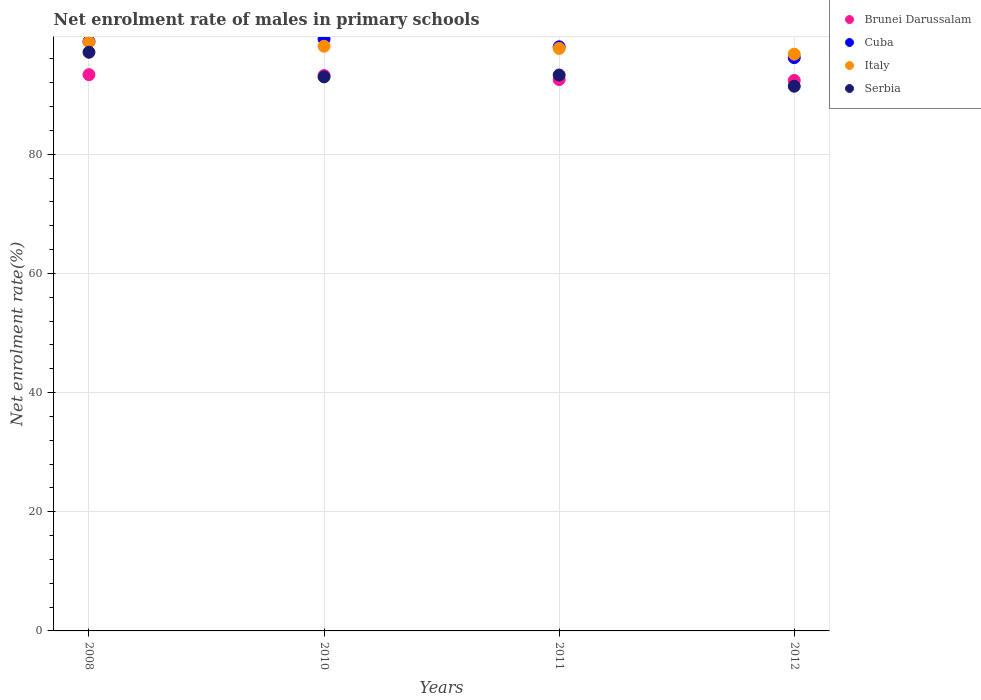How many different coloured dotlines are there?
Offer a terse response. 4. Is the number of dotlines equal to the number of legend labels?
Ensure brevity in your answer.  Yes. What is the net enrolment rate of males in primary schools in Serbia in 2012?
Your answer should be compact. 91.43. Across all years, what is the maximum net enrolment rate of males in primary schools in Cuba?
Offer a terse response. 99.36. Across all years, what is the minimum net enrolment rate of males in primary schools in Cuba?
Offer a very short reply. 96.22. What is the total net enrolment rate of males in primary schools in Serbia in the graph?
Ensure brevity in your answer.  374.85. What is the difference between the net enrolment rate of males in primary schools in Cuba in 2008 and that in 2010?
Keep it short and to the point. -0.42. What is the difference between the net enrolment rate of males in primary schools in Serbia in 2011 and the net enrolment rate of males in primary schools in Italy in 2008?
Provide a short and direct response. -5.55. What is the average net enrolment rate of males in primary schools in Italy per year?
Give a very brief answer. 97.89. In the year 2011, what is the difference between the net enrolment rate of males in primary schools in Serbia and net enrolment rate of males in primary schools in Brunei Darussalam?
Your answer should be very brief. 0.76. In how many years, is the net enrolment rate of males in primary schools in Italy greater than 76 %?
Provide a short and direct response. 4. What is the ratio of the net enrolment rate of males in primary schools in Brunei Darussalam in 2008 to that in 2010?
Your answer should be very brief. 1. What is the difference between the highest and the second highest net enrolment rate of males in primary schools in Brunei Darussalam?
Make the answer very short. 0.15. What is the difference between the highest and the lowest net enrolment rate of males in primary schools in Italy?
Provide a short and direct response. 2.05. Is the sum of the net enrolment rate of males in primary schools in Cuba in 2008 and 2010 greater than the maximum net enrolment rate of males in primary schools in Brunei Darussalam across all years?
Offer a terse response. Yes. Is it the case that in every year, the sum of the net enrolment rate of males in primary schools in Cuba and net enrolment rate of males in primary schools in Serbia  is greater than the sum of net enrolment rate of males in primary schools in Italy and net enrolment rate of males in primary schools in Brunei Darussalam?
Provide a succinct answer. Yes. Is it the case that in every year, the sum of the net enrolment rate of males in primary schools in Brunei Darussalam and net enrolment rate of males in primary schools in Italy  is greater than the net enrolment rate of males in primary schools in Serbia?
Keep it short and to the point. Yes. How many dotlines are there?
Make the answer very short. 4. How many years are there in the graph?
Keep it short and to the point. 4. What is the difference between two consecutive major ticks on the Y-axis?
Provide a succinct answer. 20. Are the values on the major ticks of Y-axis written in scientific E-notation?
Your answer should be compact. No. Does the graph contain any zero values?
Your answer should be compact. No. Does the graph contain grids?
Give a very brief answer. Yes. How many legend labels are there?
Provide a short and direct response. 4. What is the title of the graph?
Provide a succinct answer. Net enrolment rate of males in primary schools. What is the label or title of the Y-axis?
Your answer should be compact. Net enrolment rate(%). What is the Net enrolment rate(%) in Brunei Darussalam in 2008?
Provide a short and direct response. 93.37. What is the Net enrolment rate(%) of Cuba in 2008?
Your answer should be compact. 98.94. What is the Net enrolment rate(%) of Italy in 2008?
Provide a succinct answer. 98.85. What is the Net enrolment rate(%) of Serbia in 2008?
Your response must be concise. 97.13. What is the Net enrolment rate(%) of Brunei Darussalam in 2010?
Your response must be concise. 93.22. What is the Net enrolment rate(%) in Cuba in 2010?
Your answer should be compact. 99.36. What is the Net enrolment rate(%) of Italy in 2010?
Provide a succinct answer. 98.13. What is the Net enrolment rate(%) in Serbia in 2010?
Offer a very short reply. 92.99. What is the Net enrolment rate(%) of Brunei Darussalam in 2011?
Give a very brief answer. 92.54. What is the Net enrolment rate(%) in Cuba in 2011?
Your answer should be compact. 98.04. What is the Net enrolment rate(%) in Italy in 2011?
Provide a short and direct response. 97.76. What is the Net enrolment rate(%) of Serbia in 2011?
Offer a terse response. 93.3. What is the Net enrolment rate(%) of Brunei Darussalam in 2012?
Your answer should be compact. 92.39. What is the Net enrolment rate(%) in Cuba in 2012?
Give a very brief answer. 96.22. What is the Net enrolment rate(%) in Italy in 2012?
Offer a terse response. 96.8. What is the Net enrolment rate(%) of Serbia in 2012?
Your answer should be very brief. 91.43. Across all years, what is the maximum Net enrolment rate(%) of Brunei Darussalam?
Provide a succinct answer. 93.37. Across all years, what is the maximum Net enrolment rate(%) in Cuba?
Your answer should be very brief. 99.36. Across all years, what is the maximum Net enrolment rate(%) in Italy?
Ensure brevity in your answer.  98.85. Across all years, what is the maximum Net enrolment rate(%) in Serbia?
Provide a succinct answer. 97.13. Across all years, what is the minimum Net enrolment rate(%) in Brunei Darussalam?
Offer a very short reply. 92.39. Across all years, what is the minimum Net enrolment rate(%) of Cuba?
Provide a succinct answer. 96.22. Across all years, what is the minimum Net enrolment rate(%) of Italy?
Give a very brief answer. 96.8. Across all years, what is the minimum Net enrolment rate(%) in Serbia?
Give a very brief answer. 91.43. What is the total Net enrolment rate(%) in Brunei Darussalam in the graph?
Offer a terse response. 371.52. What is the total Net enrolment rate(%) in Cuba in the graph?
Your answer should be compact. 392.57. What is the total Net enrolment rate(%) of Italy in the graph?
Your answer should be very brief. 391.55. What is the total Net enrolment rate(%) of Serbia in the graph?
Give a very brief answer. 374.85. What is the difference between the Net enrolment rate(%) in Brunei Darussalam in 2008 and that in 2010?
Your response must be concise. 0.15. What is the difference between the Net enrolment rate(%) in Cuba in 2008 and that in 2010?
Provide a succinct answer. -0.42. What is the difference between the Net enrolment rate(%) of Italy in 2008 and that in 2010?
Your answer should be very brief. 0.72. What is the difference between the Net enrolment rate(%) in Serbia in 2008 and that in 2010?
Provide a short and direct response. 4.13. What is the difference between the Net enrolment rate(%) in Brunei Darussalam in 2008 and that in 2011?
Your response must be concise. 0.82. What is the difference between the Net enrolment rate(%) of Cuba in 2008 and that in 2011?
Your answer should be very brief. 0.9. What is the difference between the Net enrolment rate(%) of Italy in 2008 and that in 2011?
Your answer should be very brief. 1.09. What is the difference between the Net enrolment rate(%) of Serbia in 2008 and that in 2011?
Provide a succinct answer. 3.82. What is the difference between the Net enrolment rate(%) of Brunei Darussalam in 2008 and that in 2012?
Your answer should be very brief. 0.98. What is the difference between the Net enrolment rate(%) in Cuba in 2008 and that in 2012?
Offer a very short reply. 2.73. What is the difference between the Net enrolment rate(%) in Italy in 2008 and that in 2012?
Offer a very short reply. 2.05. What is the difference between the Net enrolment rate(%) in Serbia in 2008 and that in 2012?
Ensure brevity in your answer.  5.7. What is the difference between the Net enrolment rate(%) in Brunei Darussalam in 2010 and that in 2011?
Your response must be concise. 0.67. What is the difference between the Net enrolment rate(%) in Cuba in 2010 and that in 2011?
Ensure brevity in your answer.  1.32. What is the difference between the Net enrolment rate(%) in Italy in 2010 and that in 2011?
Your answer should be very brief. 0.37. What is the difference between the Net enrolment rate(%) in Serbia in 2010 and that in 2011?
Your response must be concise. -0.31. What is the difference between the Net enrolment rate(%) of Brunei Darussalam in 2010 and that in 2012?
Provide a short and direct response. 0.83. What is the difference between the Net enrolment rate(%) of Cuba in 2010 and that in 2012?
Your response must be concise. 3.14. What is the difference between the Net enrolment rate(%) of Italy in 2010 and that in 2012?
Provide a succinct answer. 1.33. What is the difference between the Net enrolment rate(%) of Serbia in 2010 and that in 2012?
Provide a short and direct response. 1.57. What is the difference between the Net enrolment rate(%) in Brunei Darussalam in 2011 and that in 2012?
Offer a terse response. 0.15. What is the difference between the Net enrolment rate(%) of Cuba in 2011 and that in 2012?
Provide a succinct answer. 1.82. What is the difference between the Net enrolment rate(%) in Italy in 2011 and that in 2012?
Offer a terse response. 0.96. What is the difference between the Net enrolment rate(%) of Serbia in 2011 and that in 2012?
Offer a terse response. 1.88. What is the difference between the Net enrolment rate(%) in Brunei Darussalam in 2008 and the Net enrolment rate(%) in Cuba in 2010?
Offer a terse response. -5.99. What is the difference between the Net enrolment rate(%) of Brunei Darussalam in 2008 and the Net enrolment rate(%) of Italy in 2010?
Your answer should be very brief. -4.77. What is the difference between the Net enrolment rate(%) in Brunei Darussalam in 2008 and the Net enrolment rate(%) in Serbia in 2010?
Give a very brief answer. 0.37. What is the difference between the Net enrolment rate(%) in Cuba in 2008 and the Net enrolment rate(%) in Italy in 2010?
Provide a succinct answer. 0.81. What is the difference between the Net enrolment rate(%) of Cuba in 2008 and the Net enrolment rate(%) of Serbia in 2010?
Keep it short and to the point. 5.95. What is the difference between the Net enrolment rate(%) in Italy in 2008 and the Net enrolment rate(%) in Serbia in 2010?
Provide a succinct answer. 5.86. What is the difference between the Net enrolment rate(%) in Brunei Darussalam in 2008 and the Net enrolment rate(%) in Cuba in 2011?
Make the answer very short. -4.68. What is the difference between the Net enrolment rate(%) of Brunei Darussalam in 2008 and the Net enrolment rate(%) of Italy in 2011?
Make the answer very short. -4.39. What is the difference between the Net enrolment rate(%) in Brunei Darussalam in 2008 and the Net enrolment rate(%) in Serbia in 2011?
Your answer should be compact. 0.06. What is the difference between the Net enrolment rate(%) of Cuba in 2008 and the Net enrolment rate(%) of Italy in 2011?
Your answer should be compact. 1.18. What is the difference between the Net enrolment rate(%) in Cuba in 2008 and the Net enrolment rate(%) in Serbia in 2011?
Offer a terse response. 5.64. What is the difference between the Net enrolment rate(%) of Italy in 2008 and the Net enrolment rate(%) of Serbia in 2011?
Your answer should be very brief. 5.55. What is the difference between the Net enrolment rate(%) of Brunei Darussalam in 2008 and the Net enrolment rate(%) of Cuba in 2012?
Ensure brevity in your answer.  -2.85. What is the difference between the Net enrolment rate(%) of Brunei Darussalam in 2008 and the Net enrolment rate(%) of Italy in 2012?
Keep it short and to the point. -3.43. What is the difference between the Net enrolment rate(%) in Brunei Darussalam in 2008 and the Net enrolment rate(%) in Serbia in 2012?
Your response must be concise. 1.94. What is the difference between the Net enrolment rate(%) in Cuba in 2008 and the Net enrolment rate(%) in Italy in 2012?
Offer a very short reply. 2.14. What is the difference between the Net enrolment rate(%) of Cuba in 2008 and the Net enrolment rate(%) of Serbia in 2012?
Provide a short and direct response. 7.52. What is the difference between the Net enrolment rate(%) in Italy in 2008 and the Net enrolment rate(%) in Serbia in 2012?
Offer a terse response. 7.43. What is the difference between the Net enrolment rate(%) of Brunei Darussalam in 2010 and the Net enrolment rate(%) of Cuba in 2011?
Offer a very short reply. -4.83. What is the difference between the Net enrolment rate(%) in Brunei Darussalam in 2010 and the Net enrolment rate(%) in Italy in 2011?
Provide a short and direct response. -4.54. What is the difference between the Net enrolment rate(%) in Brunei Darussalam in 2010 and the Net enrolment rate(%) in Serbia in 2011?
Provide a succinct answer. -0.09. What is the difference between the Net enrolment rate(%) in Cuba in 2010 and the Net enrolment rate(%) in Italy in 2011?
Offer a terse response. 1.6. What is the difference between the Net enrolment rate(%) in Cuba in 2010 and the Net enrolment rate(%) in Serbia in 2011?
Provide a short and direct response. 6.06. What is the difference between the Net enrolment rate(%) in Italy in 2010 and the Net enrolment rate(%) in Serbia in 2011?
Keep it short and to the point. 4.83. What is the difference between the Net enrolment rate(%) of Brunei Darussalam in 2010 and the Net enrolment rate(%) of Cuba in 2012?
Ensure brevity in your answer.  -3. What is the difference between the Net enrolment rate(%) of Brunei Darussalam in 2010 and the Net enrolment rate(%) of Italy in 2012?
Make the answer very short. -3.58. What is the difference between the Net enrolment rate(%) of Brunei Darussalam in 2010 and the Net enrolment rate(%) of Serbia in 2012?
Give a very brief answer. 1.79. What is the difference between the Net enrolment rate(%) in Cuba in 2010 and the Net enrolment rate(%) in Italy in 2012?
Your answer should be very brief. 2.56. What is the difference between the Net enrolment rate(%) in Cuba in 2010 and the Net enrolment rate(%) in Serbia in 2012?
Offer a very short reply. 7.93. What is the difference between the Net enrolment rate(%) in Italy in 2010 and the Net enrolment rate(%) in Serbia in 2012?
Ensure brevity in your answer.  6.71. What is the difference between the Net enrolment rate(%) in Brunei Darussalam in 2011 and the Net enrolment rate(%) in Cuba in 2012?
Provide a succinct answer. -3.67. What is the difference between the Net enrolment rate(%) of Brunei Darussalam in 2011 and the Net enrolment rate(%) of Italy in 2012?
Ensure brevity in your answer.  -4.26. What is the difference between the Net enrolment rate(%) in Brunei Darussalam in 2011 and the Net enrolment rate(%) in Serbia in 2012?
Ensure brevity in your answer.  1.12. What is the difference between the Net enrolment rate(%) in Cuba in 2011 and the Net enrolment rate(%) in Italy in 2012?
Provide a short and direct response. 1.24. What is the difference between the Net enrolment rate(%) in Cuba in 2011 and the Net enrolment rate(%) in Serbia in 2012?
Make the answer very short. 6.62. What is the difference between the Net enrolment rate(%) in Italy in 2011 and the Net enrolment rate(%) in Serbia in 2012?
Provide a short and direct response. 6.33. What is the average Net enrolment rate(%) in Brunei Darussalam per year?
Your answer should be compact. 92.88. What is the average Net enrolment rate(%) of Cuba per year?
Ensure brevity in your answer.  98.14. What is the average Net enrolment rate(%) of Italy per year?
Ensure brevity in your answer.  97.89. What is the average Net enrolment rate(%) of Serbia per year?
Your response must be concise. 93.71. In the year 2008, what is the difference between the Net enrolment rate(%) of Brunei Darussalam and Net enrolment rate(%) of Cuba?
Your answer should be very brief. -5.58. In the year 2008, what is the difference between the Net enrolment rate(%) of Brunei Darussalam and Net enrolment rate(%) of Italy?
Provide a short and direct response. -5.49. In the year 2008, what is the difference between the Net enrolment rate(%) of Brunei Darussalam and Net enrolment rate(%) of Serbia?
Provide a succinct answer. -3.76. In the year 2008, what is the difference between the Net enrolment rate(%) of Cuba and Net enrolment rate(%) of Italy?
Offer a very short reply. 0.09. In the year 2008, what is the difference between the Net enrolment rate(%) of Cuba and Net enrolment rate(%) of Serbia?
Your answer should be very brief. 1.82. In the year 2008, what is the difference between the Net enrolment rate(%) in Italy and Net enrolment rate(%) in Serbia?
Your response must be concise. 1.73. In the year 2010, what is the difference between the Net enrolment rate(%) in Brunei Darussalam and Net enrolment rate(%) in Cuba?
Your response must be concise. -6.14. In the year 2010, what is the difference between the Net enrolment rate(%) in Brunei Darussalam and Net enrolment rate(%) in Italy?
Your response must be concise. -4.92. In the year 2010, what is the difference between the Net enrolment rate(%) of Brunei Darussalam and Net enrolment rate(%) of Serbia?
Give a very brief answer. 0.22. In the year 2010, what is the difference between the Net enrolment rate(%) in Cuba and Net enrolment rate(%) in Italy?
Provide a succinct answer. 1.23. In the year 2010, what is the difference between the Net enrolment rate(%) in Cuba and Net enrolment rate(%) in Serbia?
Make the answer very short. 6.37. In the year 2010, what is the difference between the Net enrolment rate(%) of Italy and Net enrolment rate(%) of Serbia?
Provide a short and direct response. 5.14. In the year 2011, what is the difference between the Net enrolment rate(%) in Brunei Darussalam and Net enrolment rate(%) in Cuba?
Give a very brief answer. -5.5. In the year 2011, what is the difference between the Net enrolment rate(%) in Brunei Darussalam and Net enrolment rate(%) in Italy?
Keep it short and to the point. -5.22. In the year 2011, what is the difference between the Net enrolment rate(%) in Brunei Darussalam and Net enrolment rate(%) in Serbia?
Give a very brief answer. -0.76. In the year 2011, what is the difference between the Net enrolment rate(%) in Cuba and Net enrolment rate(%) in Italy?
Ensure brevity in your answer.  0.28. In the year 2011, what is the difference between the Net enrolment rate(%) in Cuba and Net enrolment rate(%) in Serbia?
Offer a terse response. 4.74. In the year 2011, what is the difference between the Net enrolment rate(%) in Italy and Net enrolment rate(%) in Serbia?
Keep it short and to the point. 4.46. In the year 2012, what is the difference between the Net enrolment rate(%) of Brunei Darussalam and Net enrolment rate(%) of Cuba?
Provide a succinct answer. -3.83. In the year 2012, what is the difference between the Net enrolment rate(%) in Brunei Darussalam and Net enrolment rate(%) in Italy?
Ensure brevity in your answer.  -4.41. In the year 2012, what is the difference between the Net enrolment rate(%) of Brunei Darussalam and Net enrolment rate(%) of Serbia?
Provide a succinct answer. 0.96. In the year 2012, what is the difference between the Net enrolment rate(%) of Cuba and Net enrolment rate(%) of Italy?
Make the answer very short. -0.58. In the year 2012, what is the difference between the Net enrolment rate(%) of Cuba and Net enrolment rate(%) of Serbia?
Offer a terse response. 4.79. In the year 2012, what is the difference between the Net enrolment rate(%) of Italy and Net enrolment rate(%) of Serbia?
Provide a succinct answer. 5.37. What is the ratio of the Net enrolment rate(%) in Cuba in 2008 to that in 2010?
Offer a very short reply. 1. What is the ratio of the Net enrolment rate(%) in Italy in 2008 to that in 2010?
Keep it short and to the point. 1.01. What is the ratio of the Net enrolment rate(%) of Serbia in 2008 to that in 2010?
Make the answer very short. 1.04. What is the ratio of the Net enrolment rate(%) in Brunei Darussalam in 2008 to that in 2011?
Your response must be concise. 1.01. What is the ratio of the Net enrolment rate(%) of Cuba in 2008 to that in 2011?
Offer a very short reply. 1.01. What is the ratio of the Net enrolment rate(%) of Italy in 2008 to that in 2011?
Keep it short and to the point. 1.01. What is the ratio of the Net enrolment rate(%) in Serbia in 2008 to that in 2011?
Provide a short and direct response. 1.04. What is the ratio of the Net enrolment rate(%) in Brunei Darussalam in 2008 to that in 2012?
Your response must be concise. 1.01. What is the ratio of the Net enrolment rate(%) of Cuba in 2008 to that in 2012?
Provide a succinct answer. 1.03. What is the ratio of the Net enrolment rate(%) in Italy in 2008 to that in 2012?
Give a very brief answer. 1.02. What is the ratio of the Net enrolment rate(%) in Serbia in 2008 to that in 2012?
Your answer should be compact. 1.06. What is the ratio of the Net enrolment rate(%) of Brunei Darussalam in 2010 to that in 2011?
Offer a terse response. 1.01. What is the ratio of the Net enrolment rate(%) of Cuba in 2010 to that in 2011?
Offer a very short reply. 1.01. What is the ratio of the Net enrolment rate(%) in Italy in 2010 to that in 2011?
Provide a succinct answer. 1. What is the ratio of the Net enrolment rate(%) of Serbia in 2010 to that in 2011?
Give a very brief answer. 1. What is the ratio of the Net enrolment rate(%) in Brunei Darussalam in 2010 to that in 2012?
Your response must be concise. 1.01. What is the ratio of the Net enrolment rate(%) of Cuba in 2010 to that in 2012?
Offer a very short reply. 1.03. What is the ratio of the Net enrolment rate(%) in Italy in 2010 to that in 2012?
Offer a very short reply. 1.01. What is the ratio of the Net enrolment rate(%) in Serbia in 2010 to that in 2012?
Your answer should be compact. 1.02. What is the ratio of the Net enrolment rate(%) in Brunei Darussalam in 2011 to that in 2012?
Provide a short and direct response. 1. What is the ratio of the Net enrolment rate(%) of Italy in 2011 to that in 2012?
Offer a terse response. 1.01. What is the ratio of the Net enrolment rate(%) of Serbia in 2011 to that in 2012?
Your answer should be compact. 1.02. What is the difference between the highest and the second highest Net enrolment rate(%) of Brunei Darussalam?
Provide a short and direct response. 0.15. What is the difference between the highest and the second highest Net enrolment rate(%) in Cuba?
Your answer should be very brief. 0.42. What is the difference between the highest and the second highest Net enrolment rate(%) of Italy?
Offer a very short reply. 0.72. What is the difference between the highest and the second highest Net enrolment rate(%) of Serbia?
Provide a succinct answer. 3.82. What is the difference between the highest and the lowest Net enrolment rate(%) of Brunei Darussalam?
Provide a short and direct response. 0.98. What is the difference between the highest and the lowest Net enrolment rate(%) of Cuba?
Offer a terse response. 3.14. What is the difference between the highest and the lowest Net enrolment rate(%) in Italy?
Keep it short and to the point. 2.05. What is the difference between the highest and the lowest Net enrolment rate(%) in Serbia?
Offer a terse response. 5.7. 